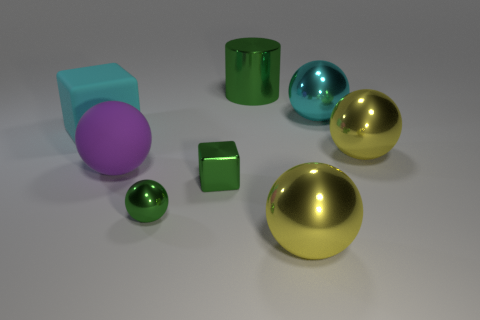Does the shiny cube have the same color as the small sphere?
Keep it short and to the point. Yes. Are there an equal number of green balls that are in front of the big green cylinder and large rubber things behind the cyan cube?
Make the answer very short. No. The big cylinder has what color?
Ensure brevity in your answer.  Green. How many things are either matte spheres that are behind the tiny metallic ball or red objects?
Your answer should be very brief. 1. There is a green thing that is behind the big matte sphere; does it have the same size as the yellow sphere that is on the left side of the big cyan shiny thing?
Provide a short and direct response. Yes. Is there any other thing that is made of the same material as the green block?
Your answer should be compact. Yes. What number of things are matte objects behind the big purple rubber ball or large cyan objects that are to the right of the metallic cylinder?
Offer a very short reply. 2. Does the large green cylinder have the same material as the cyan object that is left of the big shiny cylinder?
Offer a very short reply. No. There is a metal thing that is both in front of the cyan rubber thing and behind the big rubber sphere; what is its shape?
Ensure brevity in your answer.  Sphere. What number of other things are there of the same color as the shiny cylinder?
Keep it short and to the point. 2. 